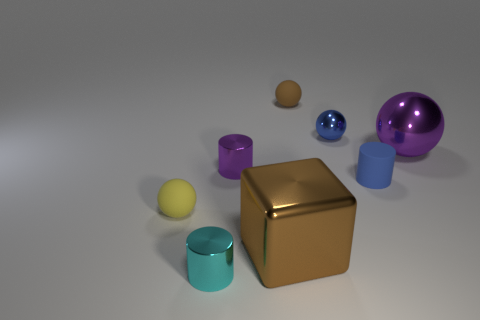Can you identify the colors of the objects and list them? Certainly! The objects display a variety of colors: there is a gold cube, a purple and a cyan cylinder, a silver sphere, a blue sphere, and a yellow sphere. Each has a distinct metallic sheen. 